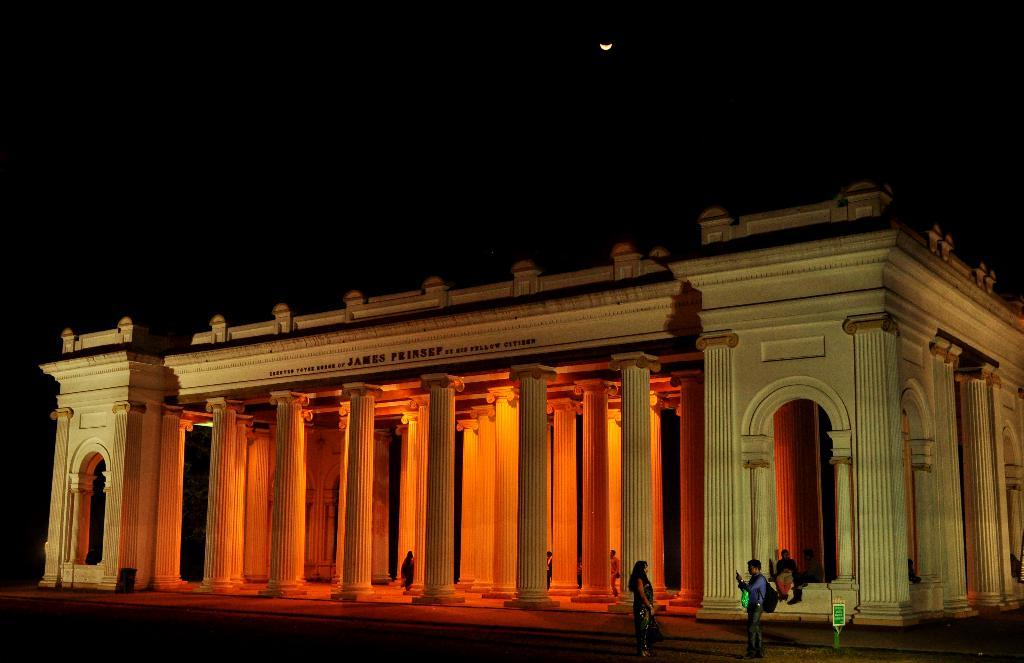What structure is the main subject of the image? There is a building in the image. Can you describe the people in the image? There are people inside the building, and two people are standing in front of the building. How would you describe the sky in the image? The sky is dark in color, and the moon is visible in the sky. What type of credit can be seen being given to the people inside the building in the image? There is no credit being given to the people inside the building in the image. What song is being played by the people standing in front of the building? There is no information about a song being played in the image. 